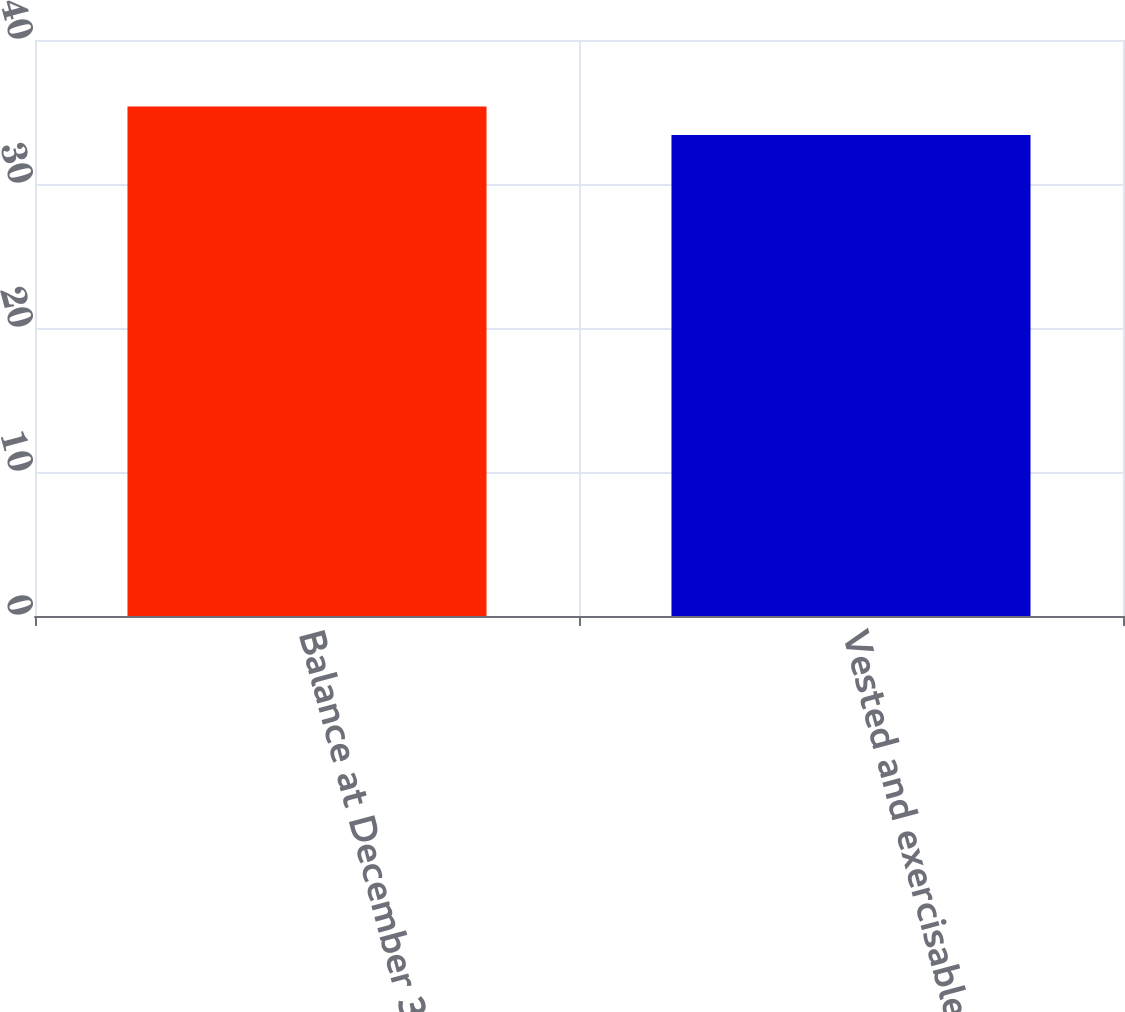<chart> <loc_0><loc_0><loc_500><loc_500><bar_chart><fcel>Balance at December 31<fcel>Vested and exercisable at<nl><fcel>35.39<fcel>33.4<nl></chart> 